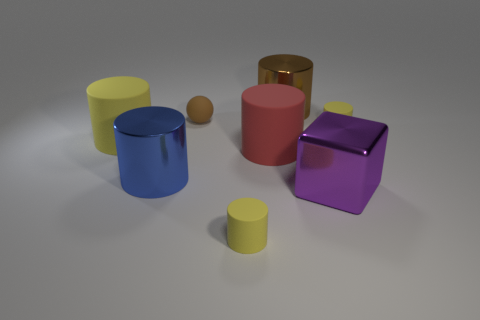Subtract all purple spheres. How many yellow cylinders are left? 3 Subtract 3 cylinders. How many cylinders are left? 3 Subtract all large blue cylinders. How many cylinders are left? 5 Subtract all blue cylinders. How many cylinders are left? 5 Subtract all purple cylinders. Subtract all gray spheres. How many cylinders are left? 6 Add 1 rubber spheres. How many objects exist? 9 Subtract all blocks. How many objects are left? 7 Add 2 large yellow cylinders. How many large yellow cylinders are left? 3 Add 8 rubber spheres. How many rubber spheres exist? 9 Subtract 0 cyan cylinders. How many objects are left? 8 